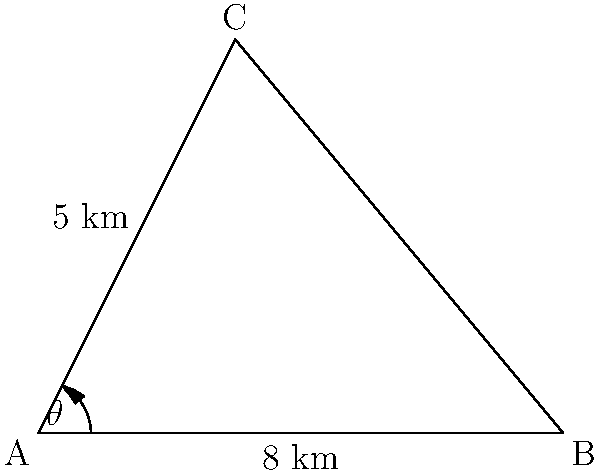As a geologist assessing mineral deposits, you need to determine the distance between two deposits (points B and C) using triangulation. From your base camp at point A, you measure the distance to deposit B as 8 km. You then travel 5 km in a straight line to deposit C. The angle $\theta$ between these two paths is measured to be 63.4°. What is the distance between deposits B and C? To solve this problem, we'll use the law of cosines. The law of cosines states that for a triangle with sides a, b, and c, and an angle C opposite the side c:

$c^2 = a^2 + b^2 - 2ab \cos(C)$

In our case:
- a = 8 km (distance from A to B)
- b = 5 km (distance from A to C)
- C = 63.4° (angle at A)
- c = distance from B to C (what we're solving for)

Let's plug these values into the formula:

$c^2 = 8^2 + 5^2 - 2(8)(5) \cos(63.4°)$

Step 1: Calculate the squares
$c^2 = 64 + 25 - 80 \cos(63.4°)$

Step 2: Calculate the cosine
$\cos(63.4°) \approx 0.4472$

Step 3: Multiply
$c^2 = 64 + 25 - 80(0.4472) = 89 - 35.776 = 53.224$

Step 4: Take the square root of both sides
$c = \sqrt{53.224} \approx 7.29$ km

Therefore, the distance between deposits B and C is approximately 7.29 km.
Answer: 7.29 km 